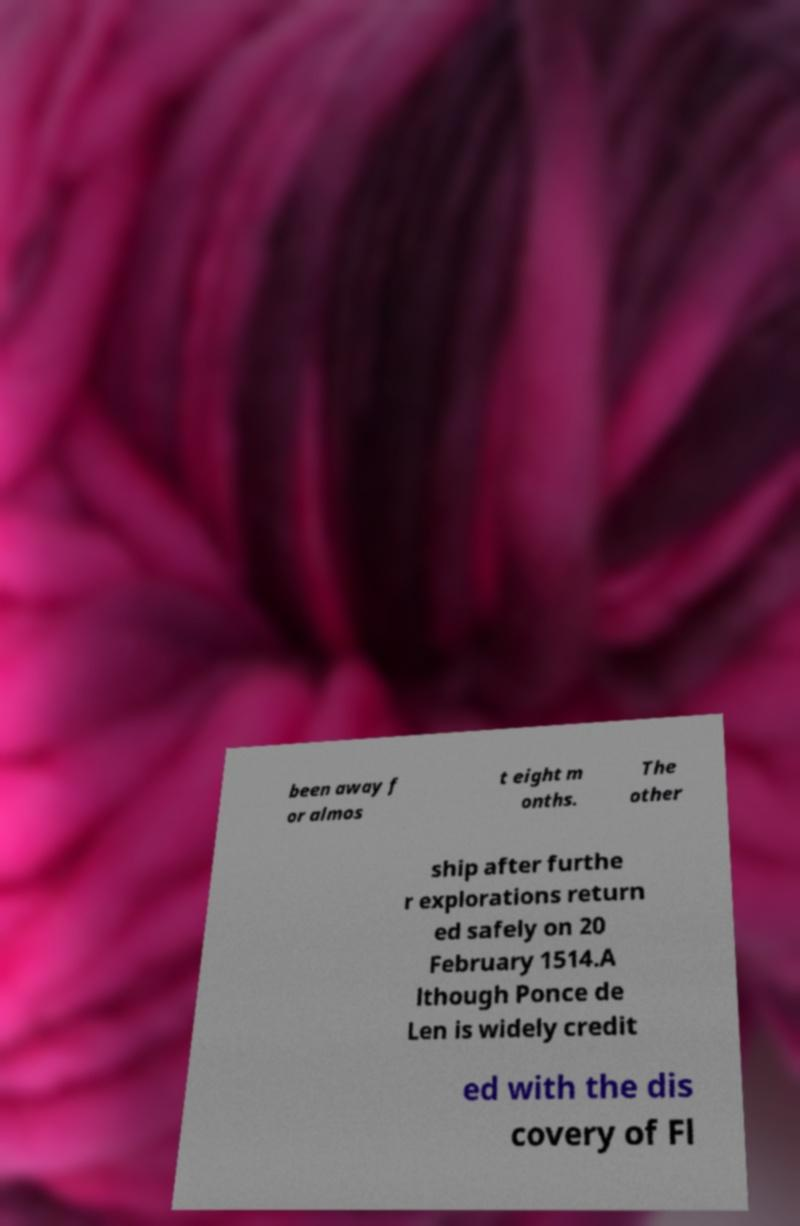There's text embedded in this image that I need extracted. Can you transcribe it verbatim? been away f or almos t eight m onths. The other ship after furthe r explorations return ed safely on 20 February 1514.A lthough Ponce de Len is widely credit ed with the dis covery of Fl 